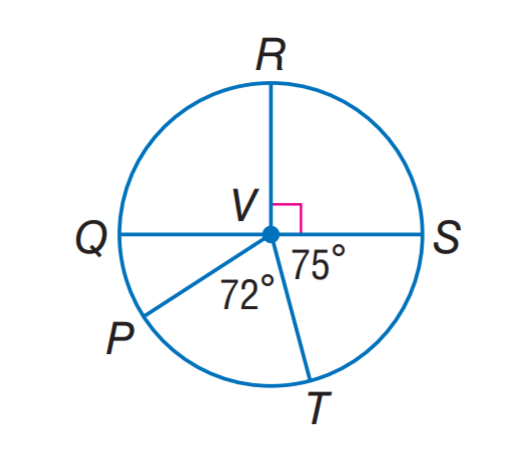Answer the mathemtical geometry problem and directly provide the correct option letter.
Question: Q S is a diameter of \odot V. Find m \widehat S T P.
Choices: A: 123 B: 144 C: 147 D: 150 C 